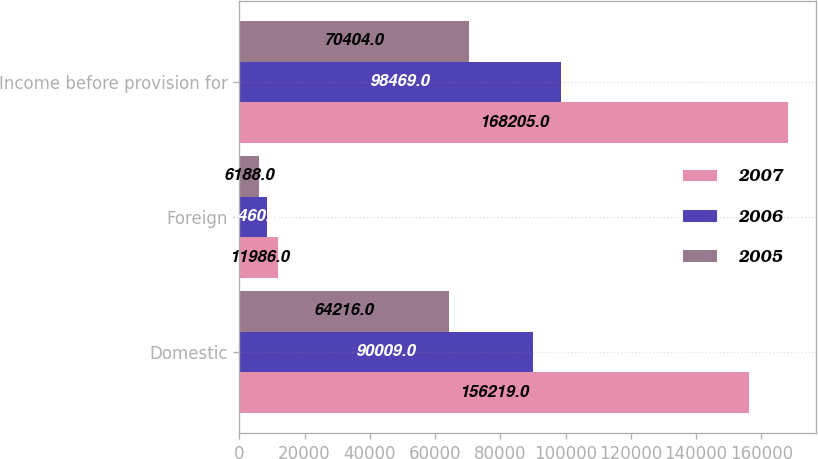<chart> <loc_0><loc_0><loc_500><loc_500><stacked_bar_chart><ecel><fcel>Domestic<fcel>Foreign<fcel>Income before provision for<nl><fcel>2007<fcel>156219<fcel>11986<fcel>168205<nl><fcel>2006<fcel>90009<fcel>8460<fcel>98469<nl><fcel>2005<fcel>64216<fcel>6188<fcel>70404<nl></chart> 